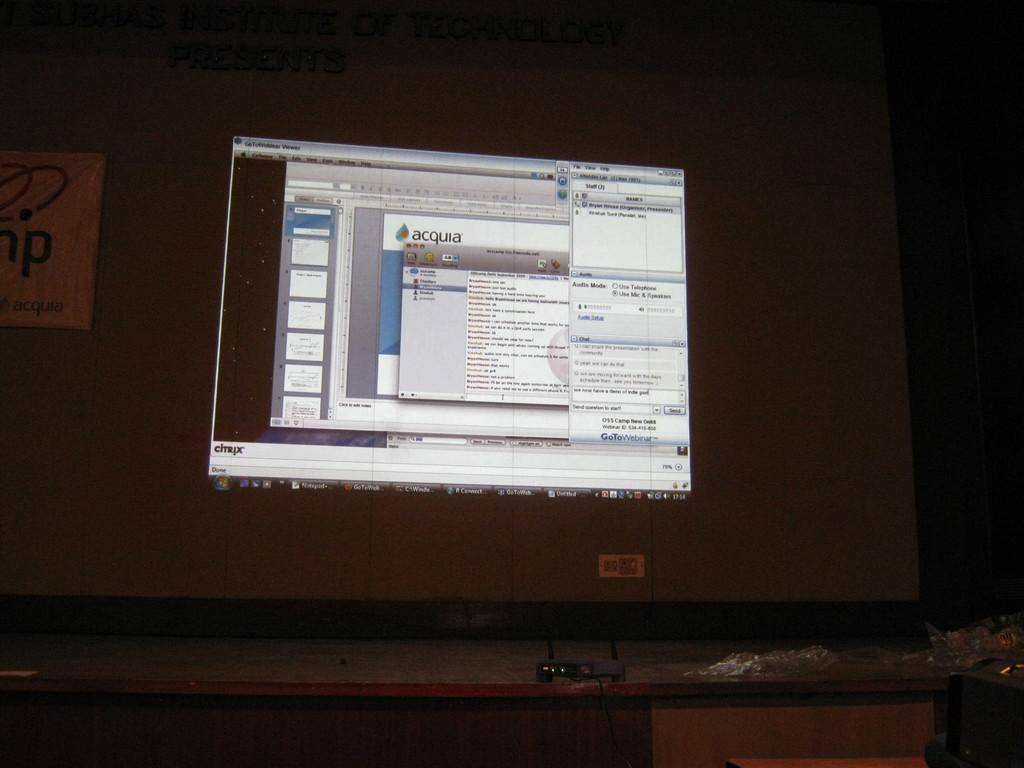<image>
Write a terse but informative summary of the picture. A computer screen having multiple windows open with the word Citrix at the bottom left corner 